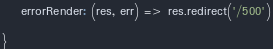<code> <loc_0><loc_0><loc_500><loc_500><_JavaScript_>
    errorRender: (res, err) => res.redirect('/500')

}
</code> 